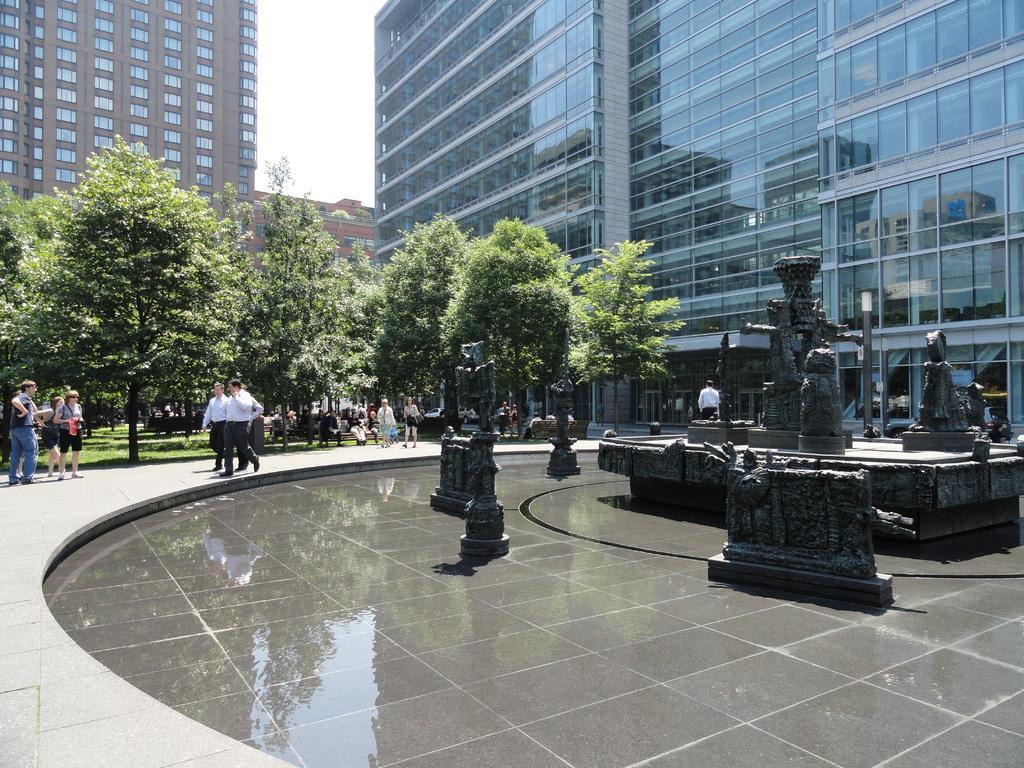Describe this image in one or two sentences. In this image I can see few persons some are standing and some are walking, in front the person is wearing white shirt, black pant. I can also see a glass building and a building in brown color, trees in green color, water. Background the sky is in white color. 